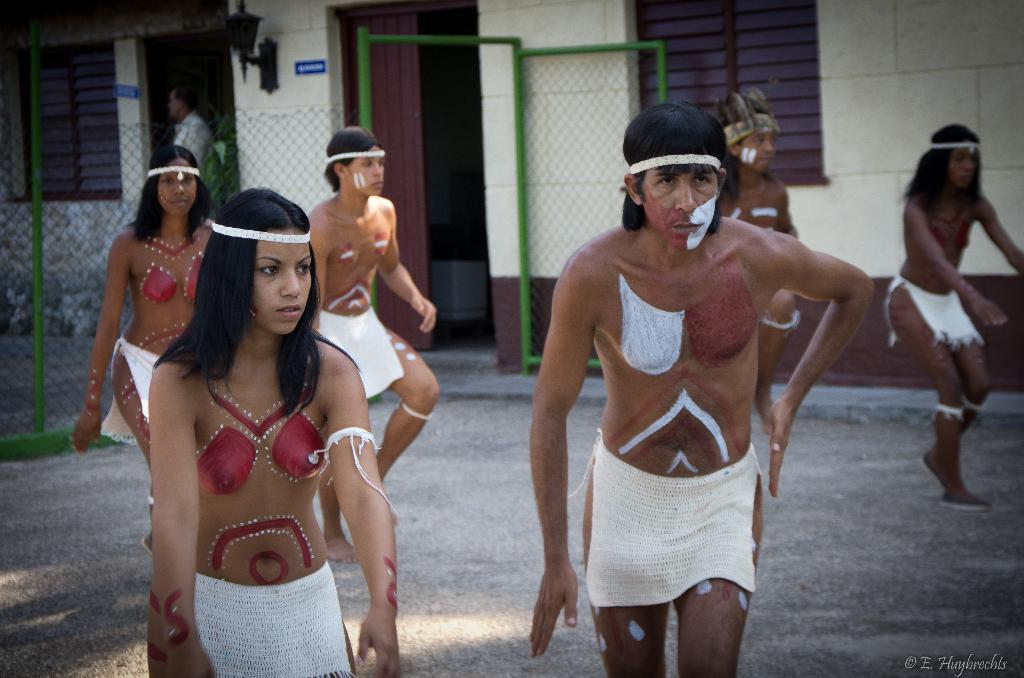Who or what can be seen in the image? There are people in the image. What are the people wearing? The people are in different costumes. What is behind the people in the image? There is net fencing behind the people. What can be seen in the distance in the image? There is a building in the background of the image. How many fish are swimming in the image? There are no fish present in the image; it features people in different costumes with net fencing and a building in the background. What team is the person in the image a part of? The image does not provide information about any specific team or organization that the people might be associated with. 